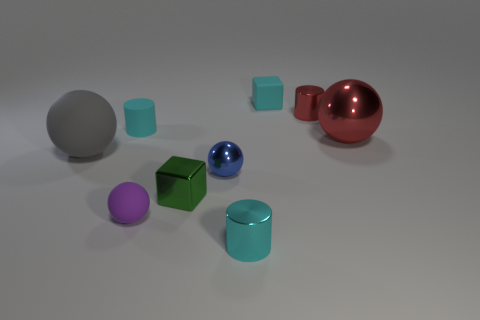The small matte thing that is the same shape as the green metallic thing is what color?
Offer a very short reply. Cyan. Is there a large gray matte object of the same shape as the small blue metal object?
Keep it short and to the point. Yes. Are there fewer yellow metal spheres than blue balls?
Your answer should be very brief. Yes. Is the tiny red thing the same shape as the big matte object?
Your response must be concise. No. What number of objects are either large brown metallic things or tiny matte things that are on the left side of the blue metal object?
Offer a very short reply. 2. What number of blue rubber blocks are there?
Your answer should be very brief. 0. Are there any purple metallic cylinders that have the same size as the purple rubber sphere?
Keep it short and to the point. No. Are there fewer small red metal objects that are in front of the small green metallic block than red shiny things?
Your response must be concise. Yes. Does the purple thing have the same size as the matte block?
Make the answer very short. Yes. What is the size of the cyan cylinder that is made of the same material as the gray sphere?
Provide a short and direct response. Small. 